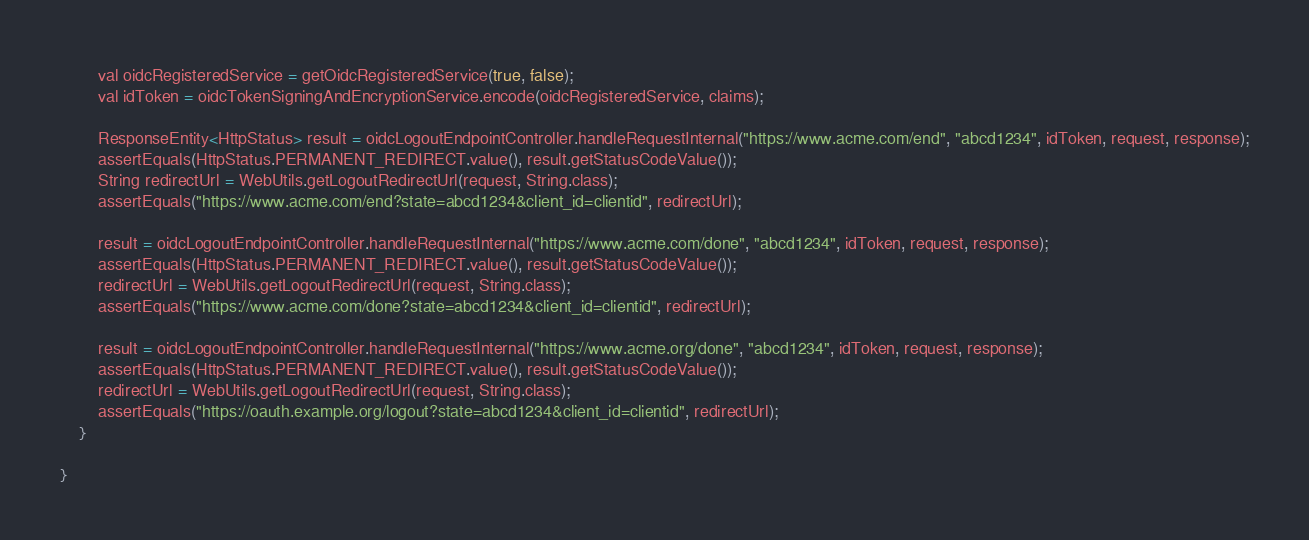<code> <loc_0><loc_0><loc_500><loc_500><_Java_>        val oidcRegisteredService = getOidcRegisteredService(true, false);
        val idToken = oidcTokenSigningAndEncryptionService.encode(oidcRegisteredService, claims);

        ResponseEntity<HttpStatus> result = oidcLogoutEndpointController.handleRequestInternal("https://www.acme.com/end", "abcd1234", idToken, request, response);
        assertEquals(HttpStatus.PERMANENT_REDIRECT.value(), result.getStatusCodeValue());
        String redirectUrl = WebUtils.getLogoutRedirectUrl(request, String.class);
        assertEquals("https://www.acme.com/end?state=abcd1234&client_id=clientid", redirectUrl);

        result = oidcLogoutEndpointController.handleRequestInternal("https://www.acme.com/done", "abcd1234", idToken, request, response);
        assertEquals(HttpStatus.PERMANENT_REDIRECT.value(), result.getStatusCodeValue());
        redirectUrl = WebUtils.getLogoutRedirectUrl(request, String.class);
        assertEquals("https://www.acme.com/done?state=abcd1234&client_id=clientid", redirectUrl);

        result = oidcLogoutEndpointController.handleRequestInternal("https://www.acme.org/done", "abcd1234", idToken, request, response);
        assertEquals(HttpStatus.PERMANENT_REDIRECT.value(), result.getStatusCodeValue());
        redirectUrl = WebUtils.getLogoutRedirectUrl(request, String.class);
        assertEquals("https://oauth.example.org/logout?state=abcd1234&client_id=clientid", redirectUrl);
    }

}
</code> 